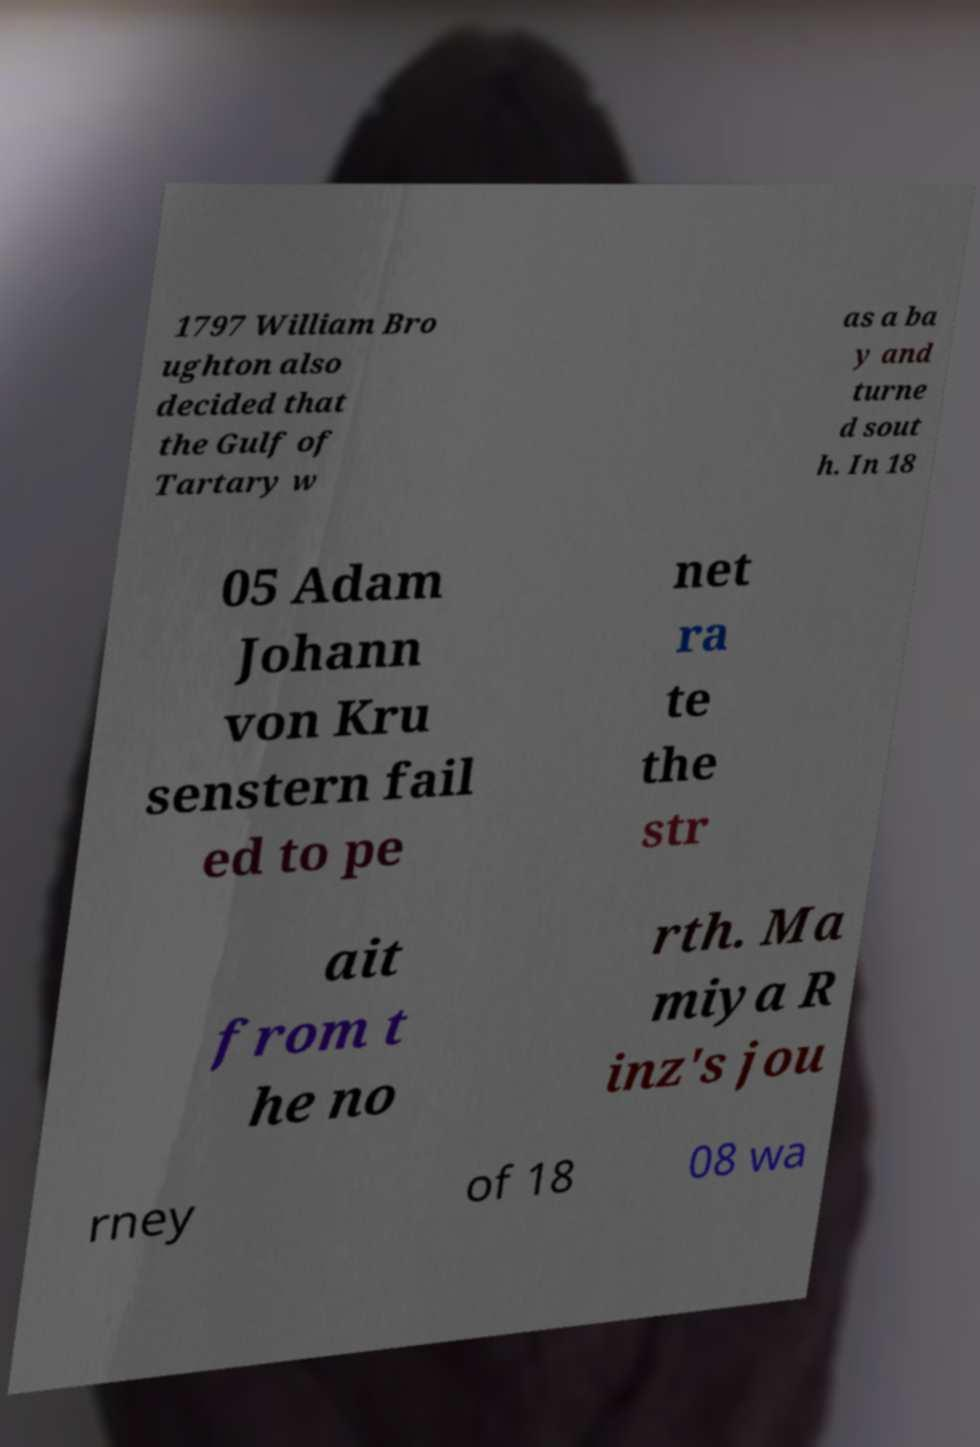Please identify and transcribe the text found in this image. 1797 William Bro ughton also decided that the Gulf of Tartary w as a ba y and turne d sout h. In 18 05 Adam Johann von Kru senstern fail ed to pe net ra te the str ait from t he no rth. Ma miya R inz's jou rney of 18 08 wa 